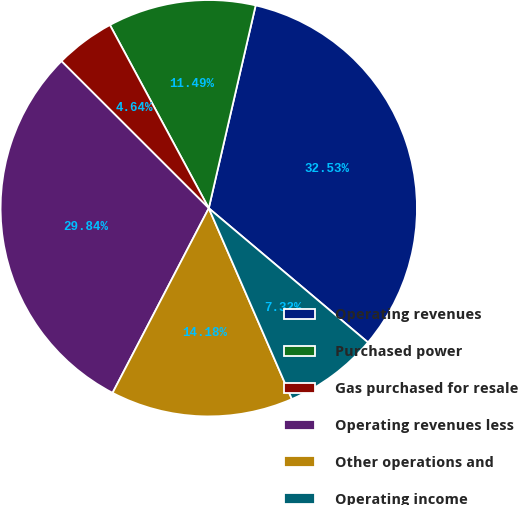Convert chart to OTSL. <chart><loc_0><loc_0><loc_500><loc_500><pie_chart><fcel>Operating revenues<fcel>Purchased power<fcel>Gas purchased for resale<fcel>Operating revenues less<fcel>Other operations and<fcel>Operating income<nl><fcel>32.53%<fcel>11.49%<fcel>4.64%<fcel>29.84%<fcel>14.18%<fcel>7.32%<nl></chart> 